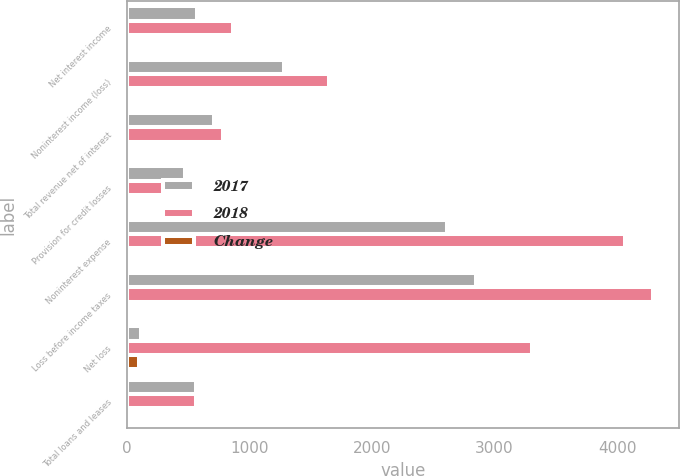Convert chart. <chart><loc_0><loc_0><loc_500><loc_500><stacked_bar_chart><ecel><fcel>Net interest income<fcel>Noninterest income (loss)<fcel>Total revenue net of interest<fcel>Provision for credit losses<fcel>Noninterest expense<fcel>Loss before income taxes<fcel>Net loss<fcel>Total loans and leases<nl><fcel>2017<fcel>573<fcel>1284<fcel>711<fcel>476<fcel>2614<fcel>2849<fcel>113<fcel>567<nl><fcel>2018<fcel>864<fcel>1648<fcel>784<fcel>561<fcel>4065<fcel>4288<fcel>3309<fcel>567<nl><fcel>Change<fcel>34<fcel>22<fcel>9<fcel>15<fcel>36<fcel>34<fcel>97<fcel>26<nl></chart> 